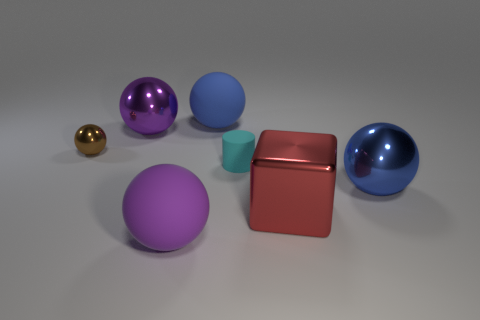Subtract all brown spheres. How many spheres are left? 4 Subtract 2 spheres. How many spheres are left? 3 Add 3 purple things. How many objects exist? 10 Subtract all cylinders. How many objects are left? 6 Add 1 big rubber objects. How many big rubber objects are left? 3 Add 1 big blue things. How many big blue things exist? 3 Subtract 0 green cylinders. How many objects are left? 7 Subtract all small cylinders. Subtract all tiny cylinders. How many objects are left? 5 